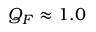<formula> <loc_0><loc_0><loc_500><loc_500>Q _ { F } \approx 1 . 0</formula> 